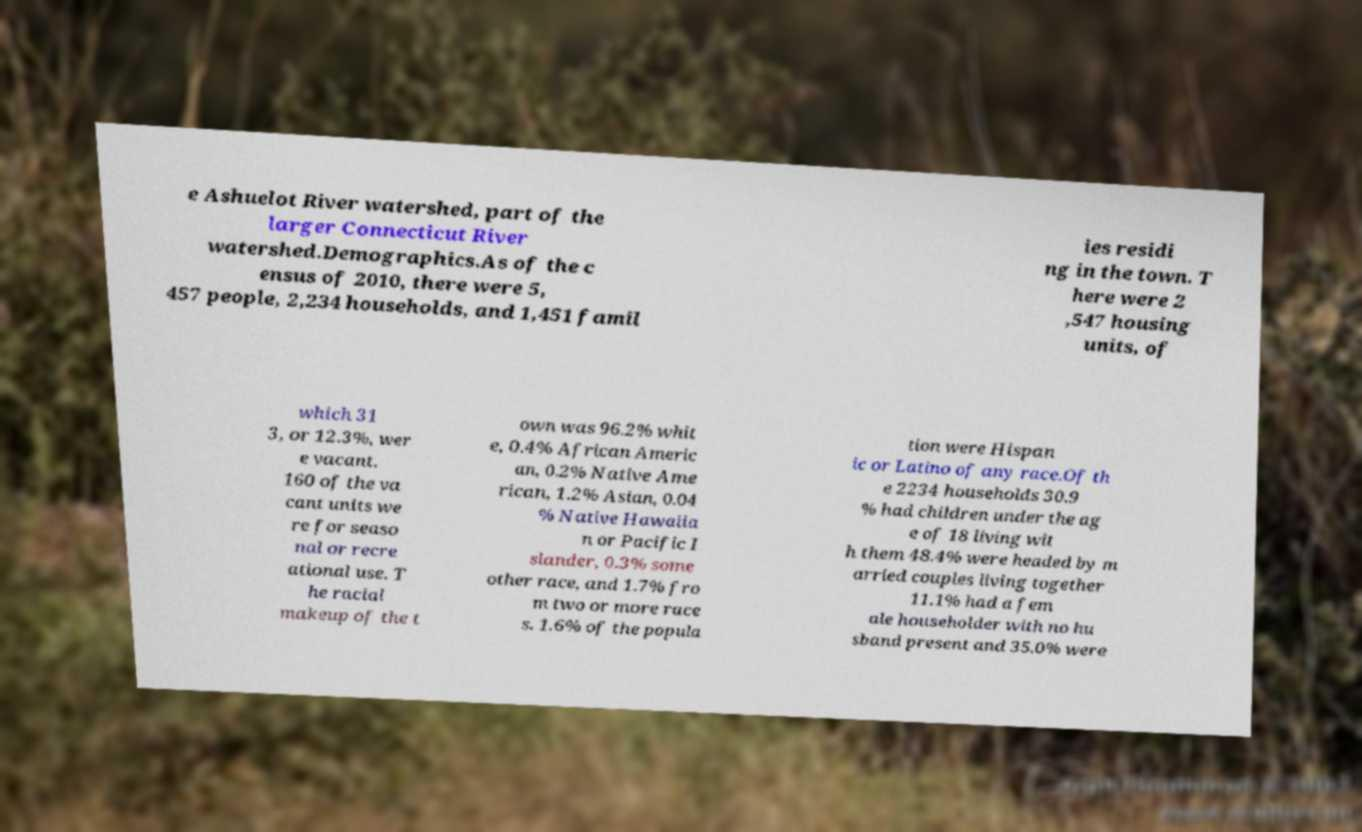Could you assist in decoding the text presented in this image and type it out clearly? e Ashuelot River watershed, part of the larger Connecticut River watershed.Demographics.As of the c ensus of 2010, there were 5, 457 people, 2,234 households, and 1,451 famil ies residi ng in the town. T here were 2 ,547 housing units, of which 31 3, or 12.3%, wer e vacant. 160 of the va cant units we re for seaso nal or recre ational use. T he racial makeup of the t own was 96.2% whit e, 0.4% African Americ an, 0.2% Native Ame rican, 1.2% Asian, 0.04 % Native Hawaiia n or Pacific I slander, 0.3% some other race, and 1.7% fro m two or more race s. 1.6% of the popula tion were Hispan ic or Latino of any race.Of th e 2234 households 30.9 % had children under the ag e of 18 living wit h them 48.4% were headed by m arried couples living together 11.1% had a fem ale householder with no hu sband present and 35.0% were 